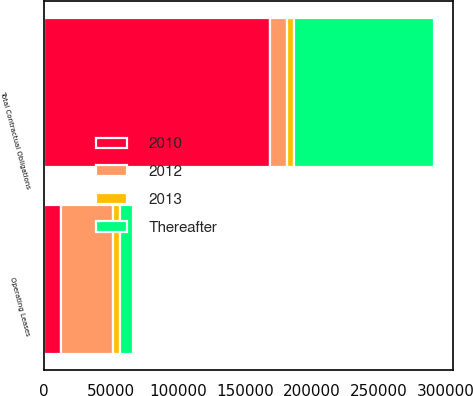<chart> <loc_0><loc_0><loc_500><loc_500><stacked_bar_chart><ecel><fcel>Operating Leases<fcel>Total Contractual Obligations<nl><fcel>2012<fcel>38886<fcel>12538<nl><fcel>2010<fcel>12538<fcel>169009<nl><fcel>Thereafter<fcel>9970<fcel>104183<nl><fcel>2013<fcel>5174<fcel>5194<nl></chart> 